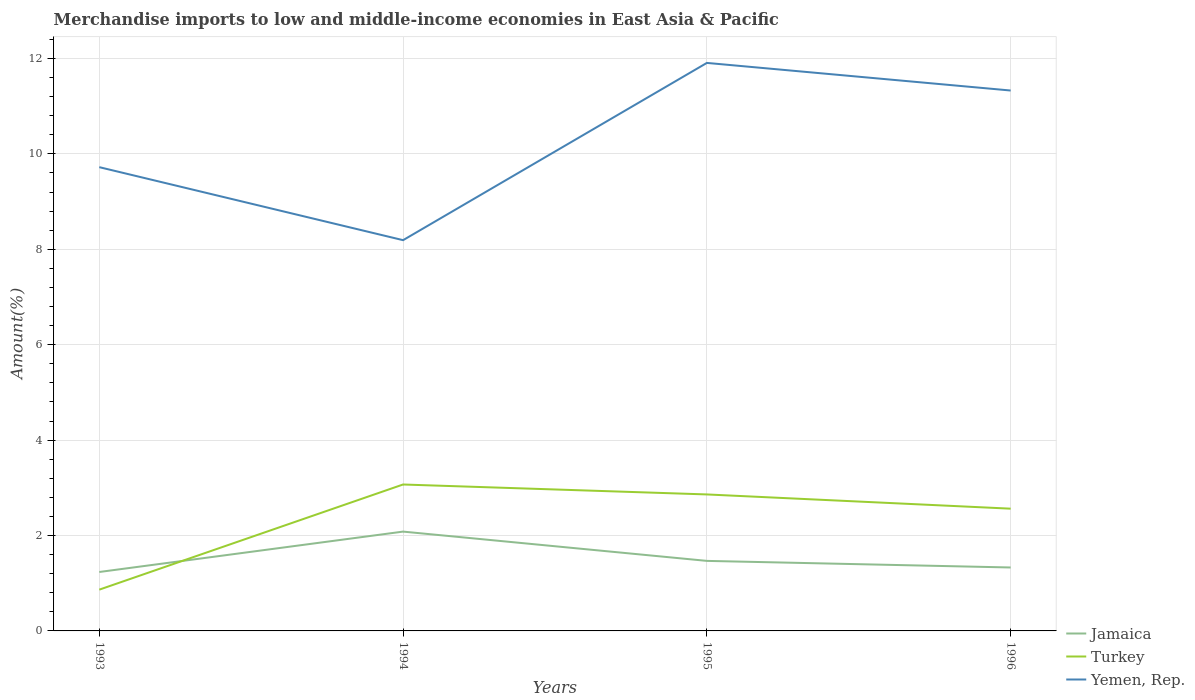How many different coloured lines are there?
Keep it short and to the point. 3. Does the line corresponding to Jamaica intersect with the line corresponding to Yemen, Rep.?
Offer a terse response. No. Is the number of lines equal to the number of legend labels?
Provide a succinct answer. Yes. Across all years, what is the maximum percentage of amount earned from merchandise imports in Yemen, Rep.?
Your response must be concise. 8.19. What is the total percentage of amount earned from merchandise imports in Turkey in the graph?
Provide a succinct answer. 0.3. What is the difference between the highest and the second highest percentage of amount earned from merchandise imports in Yemen, Rep.?
Give a very brief answer. 3.72. What is the difference between the highest and the lowest percentage of amount earned from merchandise imports in Turkey?
Offer a very short reply. 3. How many lines are there?
Your answer should be compact. 3. What is the difference between two consecutive major ticks on the Y-axis?
Provide a succinct answer. 2. What is the title of the graph?
Your answer should be compact. Merchandise imports to low and middle-income economies in East Asia & Pacific. What is the label or title of the X-axis?
Provide a succinct answer. Years. What is the label or title of the Y-axis?
Offer a very short reply. Amount(%). What is the Amount(%) of Jamaica in 1993?
Offer a very short reply. 1.24. What is the Amount(%) in Turkey in 1993?
Keep it short and to the point. 0.87. What is the Amount(%) of Yemen, Rep. in 1993?
Provide a short and direct response. 9.72. What is the Amount(%) of Jamaica in 1994?
Keep it short and to the point. 2.08. What is the Amount(%) in Turkey in 1994?
Provide a succinct answer. 3.07. What is the Amount(%) in Yemen, Rep. in 1994?
Offer a very short reply. 8.19. What is the Amount(%) in Jamaica in 1995?
Make the answer very short. 1.47. What is the Amount(%) of Turkey in 1995?
Offer a terse response. 2.86. What is the Amount(%) in Yemen, Rep. in 1995?
Make the answer very short. 11.91. What is the Amount(%) of Jamaica in 1996?
Ensure brevity in your answer.  1.33. What is the Amount(%) in Turkey in 1996?
Your answer should be compact. 2.56. What is the Amount(%) in Yemen, Rep. in 1996?
Provide a succinct answer. 11.33. Across all years, what is the maximum Amount(%) in Jamaica?
Make the answer very short. 2.08. Across all years, what is the maximum Amount(%) in Turkey?
Your response must be concise. 3.07. Across all years, what is the maximum Amount(%) in Yemen, Rep.?
Provide a short and direct response. 11.91. Across all years, what is the minimum Amount(%) of Jamaica?
Your answer should be compact. 1.24. Across all years, what is the minimum Amount(%) in Turkey?
Provide a short and direct response. 0.87. Across all years, what is the minimum Amount(%) in Yemen, Rep.?
Give a very brief answer. 8.19. What is the total Amount(%) in Jamaica in the graph?
Your answer should be compact. 6.11. What is the total Amount(%) in Turkey in the graph?
Ensure brevity in your answer.  9.36. What is the total Amount(%) of Yemen, Rep. in the graph?
Ensure brevity in your answer.  41.15. What is the difference between the Amount(%) in Jamaica in 1993 and that in 1994?
Provide a short and direct response. -0.85. What is the difference between the Amount(%) in Turkey in 1993 and that in 1994?
Your response must be concise. -2.2. What is the difference between the Amount(%) of Yemen, Rep. in 1993 and that in 1994?
Offer a terse response. 1.53. What is the difference between the Amount(%) in Jamaica in 1993 and that in 1995?
Your answer should be very brief. -0.23. What is the difference between the Amount(%) of Turkey in 1993 and that in 1995?
Your answer should be compact. -2. What is the difference between the Amount(%) in Yemen, Rep. in 1993 and that in 1995?
Provide a succinct answer. -2.19. What is the difference between the Amount(%) in Jamaica in 1993 and that in 1996?
Your answer should be very brief. -0.09. What is the difference between the Amount(%) in Turkey in 1993 and that in 1996?
Provide a short and direct response. -1.7. What is the difference between the Amount(%) in Yemen, Rep. in 1993 and that in 1996?
Provide a succinct answer. -1.61. What is the difference between the Amount(%) in Jamaica in 1994 and that in 1995?
Make the answer very short. 0.61. What is the difference between the Amount(%) in Turkey in 1994 and that in 1995?
Give a very brief answer. 0.21. What is the difference between the Amount(%) in Yemen, Rep. in 1994 and that in 1995?
Keep it short and to the point. -3.72. What is the difference between the Amount(%) in Jamaica in 1994 and that in 1996?
Keep it short and to the point. 0.75. What is the difference between the Amount(%) in Turkey in 1994 and that in 1996?
Provide a succinct answer. 0.51. What is the difference between the Amount(%) of Yemen, Rep. in 1994 and that in 1996?
Your answer should be very brief. -3.14. What is the difference between the Amount(%) in Jamaica in 1995 and that in 1996?
Make the answer very short. 0.14. What is the difference between the Amount(%) of Turkey in 1995 and that in 1996?
Your response must be concise. 0.3. What is the difference between the Amount(%) of Yemen, Rep. in 1995 and that in 1996?
Ensure brevity in your answer.  0.58. What is the difference between the Amount(%) of Jamaica in 1993 and the Amount(%) of Turkey in 1994?
Offer a terse response. -1.83. What is the difference between the Amount(%) in Jamaica in 1993 and the Amount(%) in Yemen, Rep. in 1994?
Offer a terse response. -6.96. What is the difference between the Amount(%) in Turkey in 1993 and the Amount(%) in Yemen, Rep. in 1994?
Make the answer very short. -7.33. What is the difference between the Amount(%) of Jamaica in 1993 and the Amount(%) of Turkey in 1995?
Your answer should be compact. -1.63. What is the difference between the Amount(%) in Jamaica in 1993 and the Amount(%) in Yemen, Rep. in 1995?
Offer a very short reply. -10.67. What is the difference between the Amount(%) in Turkey in 1993 and the Amount(%) in Yemen, Rep. in 1995?
Your answer should be compact. -11.04. What is the difference between the Amount(%) in Jamaica in 1993 and the Amount(%) in Turkey in 1996?
Your answer should be compact. -1.33. What is the difference between the Amount(%) in Jamaica in 1993 and the Amount(%) in Yemen, Rep. in 1996?
Provide a succinct answer. -10.09. What is the difference between the Amount(%) of Turkey in 1993 and the Amount(%) of Yemen, Rep. in 1996?
Make the answer very short. -10.46. What is the difference between the Amount(%) of Jamaica in 1994 and the Amount(%) of Turkey in 1995?
Ensure brevity in your answer.  -0.78. What is the difference between the Amount(%) of Jamaica in 1994 and the Amount(%) of Yemen, Rep. in 1995?
Keep it short and to the point. -9.82. What is the difference between the Amount(%) in Turkey in 1994 and the Amount(%) in Yemen, Rep. in 1995?
Your answer should be compact. -8.84. What is the difference between the Amount(%) in Jamaica in 1994 and the Amount(%) in Turkey in 1996?
Ensure brevity in your answer.  -0.48. What is the difference between the Amount(%) in Jamaica in 1994 and the Amount(%) in Yemen, Rep. in 1996?
Offer a terse response. -9.25. What is the difference between the Amount(%) in Turkey in 1994 and the Amount(%) in Yemen, Rep. in 1996?
Offer a terse response. -8.26. What is the difference between the Amount(%) in Jamaica in 1995 and the Amount(%) in Turkey in 1996?
Your answer should be very brief. -1.09. What is the difference between the Amount(%) of Jamaica in 1995 and the Amount(%) of Yemen, Rep. in 1996?
Your answer should be compact. -9.86. What is the difference between the Amount(%) in Turkey in 1995 and the Amount(%) in Yemen, Rep. in 1996?
Your response must be concise. -8.47. What is the average Amount(%) of Jamaica per year?
Your response must be concise. 1.53. What is the average Amount(%) in Turkey per year?
Make the answer very short. 2.34. What is the average Amount(%) in Yemen, Rep. per year?
Provide a short and direct response. 10.29. In the year 1993, what is the difference between the Amount(%) in Jamaica and Amount(%) in Turkey?
Your answer should be compact. 0.37. In the year 1993, what is the difference between the Amount(%) of Jamaica and Amount(%) of Yemen, Rep.?
Keep it short and to the point. -8.49. In the year 1993, what is the difference between the Amount(%) of Turkey and Amount(%) of Yemen, Rep.?
Offer a terse response. -8.86. In the year 1994, what is the difference between the Amount(%) in Jamaica and Amount(%) in Turkey?
Your response must be concise. -0.99. In the year 1994, what is the difference between the Amount(%) of Jamaica and Amount(%) of Yemen, Rep.?
Provide a succinct answer. -6.11. In the year 1994, what is the difference between the Amount(%) of Turkey and Amount(%) of Yemen, Rep.?
Offer a terse response. -5.12. In the year 1995, what is the difference between the Amount(%) in Jamaica and Amount(%) in Turkey?
Keep it short and to the point. -1.39. In the year 1995, what is the difference between the Amount(%) in Jamaica and Amount(%) in Yemen, Rep.?
Give a very brief answer. -10.44. In the year 1995, what is the difference between the Amount(%) of Turkey and Amount(%) of Yemen, Rep.?
Your response must be concise. -9.05. In the year 1996, what is the difference between the Amount(%) in Jamaica and Amount(%) in Turkey?
Make the answer very short. -1.23. In the year 1996, what is the difference between the Amount(%) of Jamaica and Amount(%) of Yemen, Rep.?
Make the answer very short. -10. In the year 1996, what is the difference between the Amount(%) in Turkey and Amount(%) in Yemen, Rep.?
Keep it short and to the point. -8.77. What is the ratio of the Amount(%) in Jamaica in 1993 to that in 1994?
Your answer should be compact. 0.59. What is the ratio of the Amount(%) in Turkey in 1993 to that in 1994?
Provide a short and direct response. 0.28. What is the ratio of the Amount(%) in Yemen, Rep. in 1993 to that in 1994?
Ensure brevity in your answer.  1.19. What is the ratio of the Amount(%) of Jamaica in 1993 to that in 1995?
Your answer should be very brief. 0.84. What is the ratio of the Amount(%) in Turkey in 1993 to that in 1995?
Give a very brief answer. 0.3. What is the ratio of the Amount(%) in Yemen, Rep. in 1993 to that in 1995?
Ensure brevity in your answer.  0.82. What is the ratio of the Amount(%) of Jamaica in 1993 to that in 1996?
Your answer should be very brief. 0.93. What is the ratio of the Amount(%) of Turkey in 1993 to that in 1996?
Provide a succinct answer. 0.34. What is the ratio of the Amount(%) of Yemen, Rep. in 1993 to that in 1996?
Your response must be concise. 0.86. What is the ratio of the Amount(%) in Jamaica in 1994 to that in 1995?
Make the answer very short. 1.42. What is the ratio of the Amount(%) of Turkey in 1994 to that in 1995?
Offer a very short reply. 1.07. What is the ratio of the Amount(%) of Yemen, Rep. in 1994 to that in 1995?
Your response must be concise. 0.69. What is the ratio of the Amount(%) in Jamaica in 1994 to that in 1996?
Offer a very short reply. 1.57. What is the ratio of the Amount(%) in Turkey in 1994 to that in 1996?
Ensure brevity in your answer.  1.2. What is the ratio of the Amount(%) of Yemen, Rep. in 1994 to that in 1996?
Offer a terse response. 0.72. What is the ratio of the Amount(%) in Jamaica in 1995 to that in 1996?
Offer a very short reply. 1.1. What is the ratio of the Amount(%) of Turkey in 1995 to that in 1996?
Your answer should be very brief. 1.12. What is the ratio of the Amount(%) of Yemen, Rep. in 1995 to that in 1996?
Give a very brief answer. 1.05. What is the difference between the highest and the second highest Amount(%) of Jamaica?
Give a very brief answer. 0.61. What is the difference between the highest and the second highest Amount(%) of Turkey?
Keep it short and to the point. 0.21. What is the difference between the highest and the second highest Amount(%) in Yemen, Rep.?
Provide a short and direct response. 0.58. What is the difference between the highest and the lowest Amount(%) of Jamaica?
Your answer should be compact. 0.85. What is the difference between the highest and the lowest Amount(%) in Turkey?
Keep it short and to the point. 2.2. What is the difference between the highest and the lowest Amount(%) of Yemen, Rep.?
Make the answer very short. 3.72. 